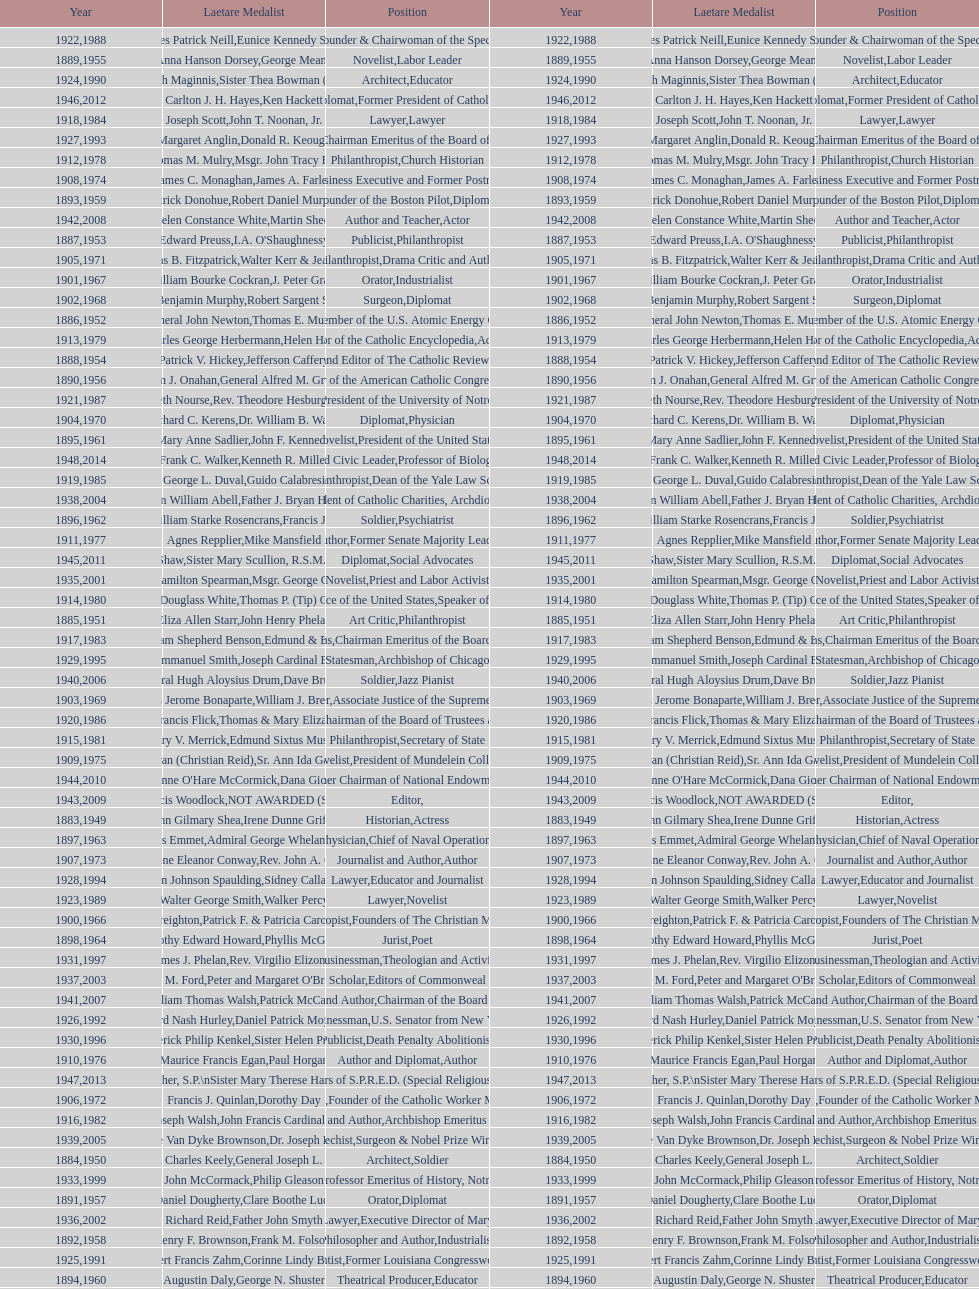Who was the previous winner before john henry phelan in 1951? General Joseph L. Collins. 